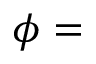Convert formula to latex. <formula><loc_0><loc_0><loc_500><loc_500>\phi =</formula> 